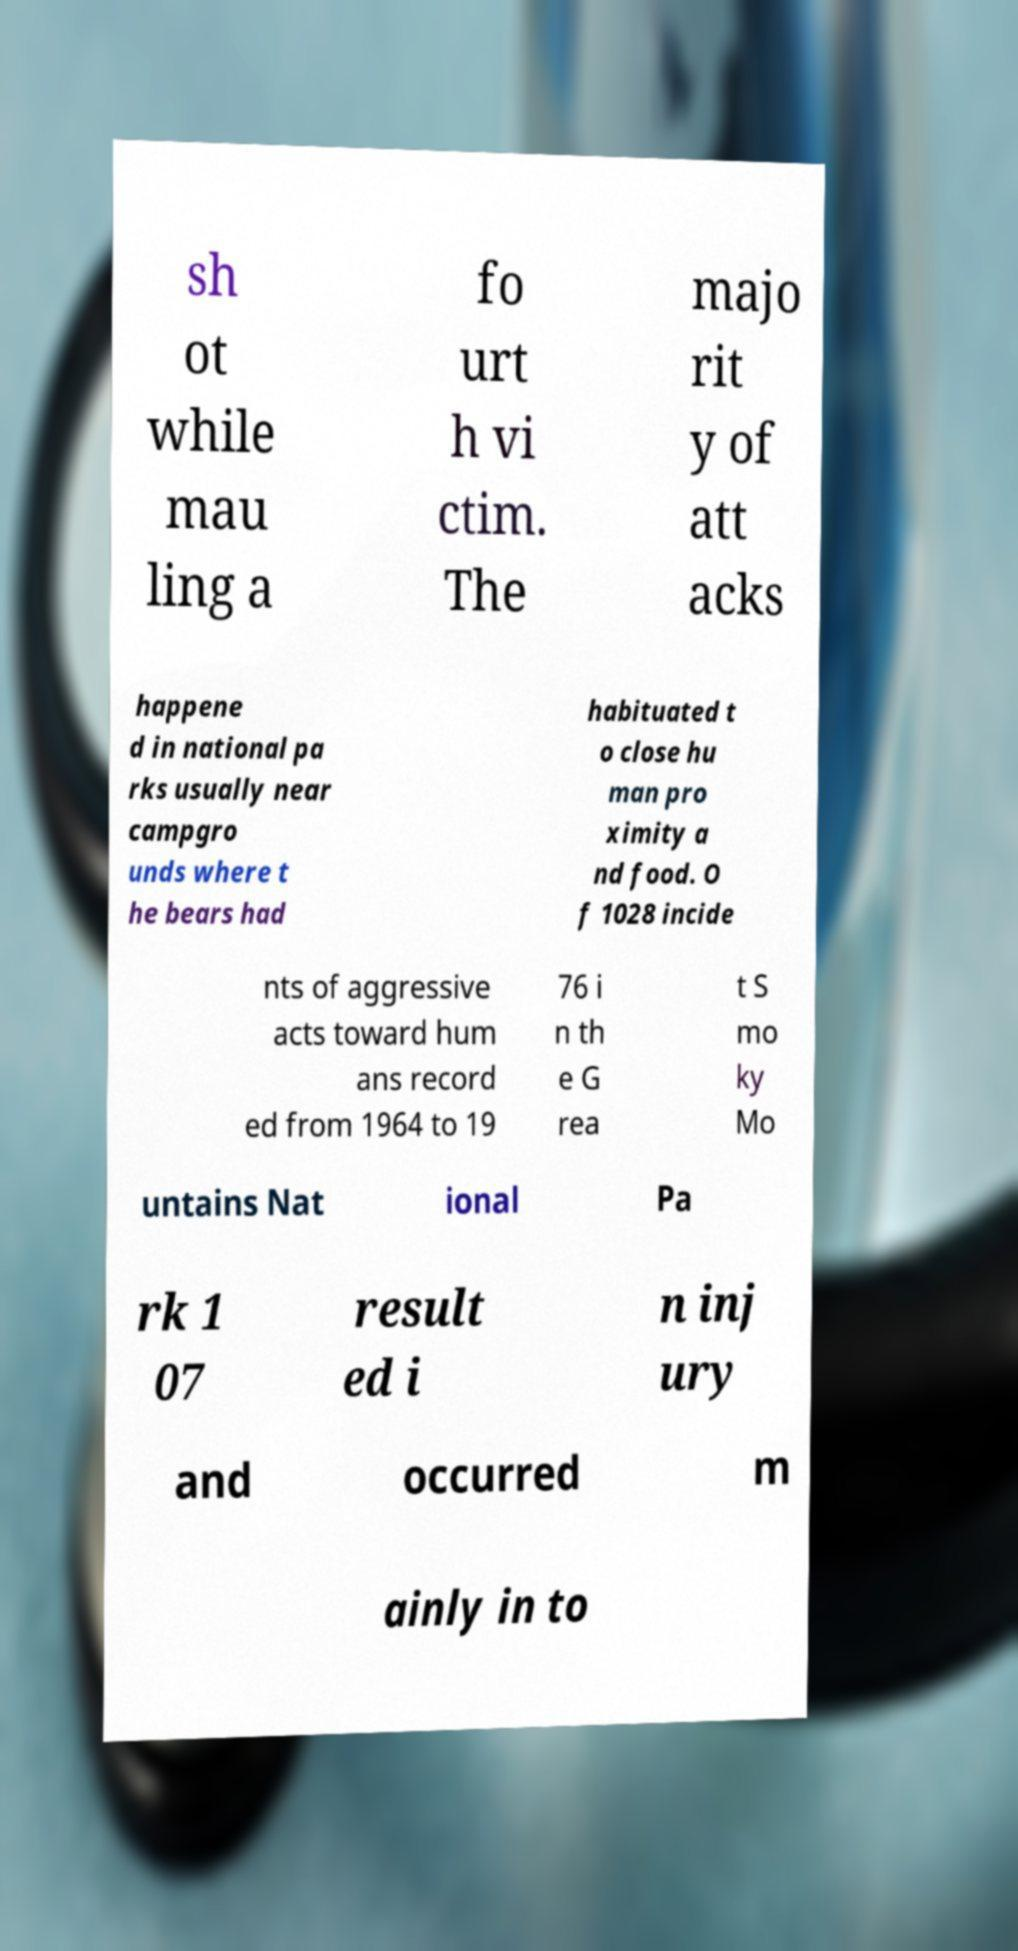Can you read and provide the text displayed in the image?This photo seems to have some interesting text. Can you extract and type it out for me? sh ot while mau ling a fo urt h vi ctim. The majo rit y of att acks happene d in national pa rks usually near campgro unds where t he bears had habituated t o close hu man pro ximity a nd food. O f 1028 incide nts of aggressive acts toward hum ans record ed from 1964 to 19 76 i n th e G rea t S mo ky Mo untains Nat ional Pa rk 1 07 result ed i n inj ury and occurred m ainly in to 